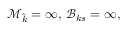<formula> <loc_0><loc_0><loc_500><loc_500>\mathcal { M } _ { \widehat { k } } = \infty , \, \mathcal { B } _ { k s } = \infty ,</formula> 